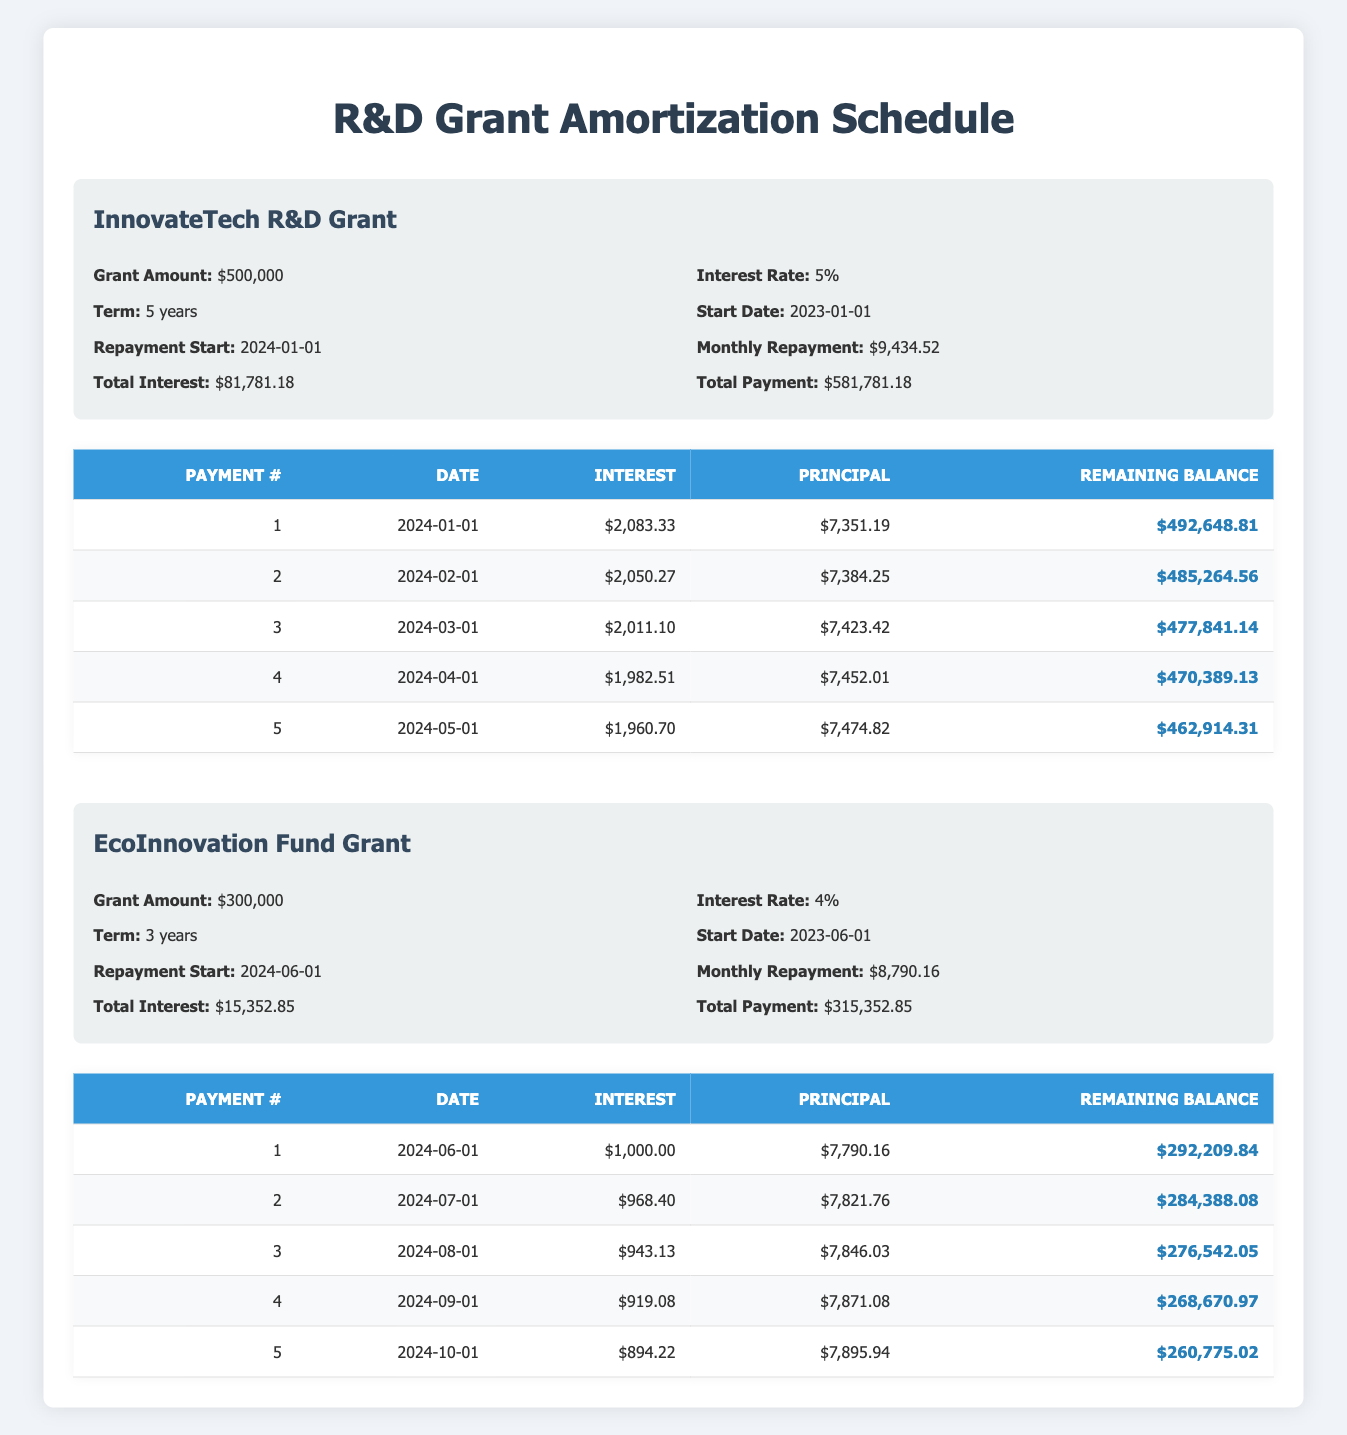What is the total payment amount for the InnovateTech R&D Grant? According to the table, the total payment for the InnovateTech R&D Grant is listed as $581,781.18.
Answer: $581,781.18 What is the remaining balance after the second payment for the EcoInnovation Fund Grant? From the payment schedule, after the second payment, the remaining balance for the EcoInnovation Fund Grant is $284,388.08.
Answer: $284,388.08 Is the monthly repayment amount for the InnovateTech R&D Grant higher than that for the EcoInnovation Fund Grant? The monthly repayment for the InnovateTech R&D Grant is $9,434.52, while for the EcoInnovation Fund Grant, it is $8,790.16. Since $9,434.52 is greater than $8,790.16, the statement is true.
Answer: Yes Calculate the average interest payment in the first five months for the InnovateTech R&D Grant. The total interest payments for the first five months are $2,083.33 + $2,050.27 + $2,011.10 + $1,982.51 + $1,960.70 = $10,087.91. Dividing this by 5 gives an average of $10,087.91 / 5 = $2,017.58.
Answer: $2,017.58 What is the difference between the total interest of the two grants? The total interest for the InnovateTech R&D Grant is $81,781.18 and for the EcoInnovation Fund Grant, it is $15,352.85. The difference is $81,781.18 - $15,352.85 = $66,428.33.
Answer: $66,428.33 How many principal payments exceed $7,400 for the InnovateTech R&D Grant? Looking at the principal payments listed for each month, the amounts are $7,351.19, $7,384.25, $7,423.42, $7,452.01, and $7,474.82. The last four payments exceed $7,400 — hence, there are four payments that exceed this amount.
Answer: 4 What is the remaining balance after the first payment of the EcoInnovation Fund Grant? The remaining balance after the first payment is shown in the payment schedule as $292,209.84 after the payment dated 2024-06-01.
Answer: $292,209.84 Does the interest payment increase with each subsequent payment for the EcoInnovation Fund Grant? Analyzing the interest payments, they are $1,000.00, $968.40, $943.13, $919.08, and $894.22, indicating that the interest payments decrease rather than increase. Thus, the statement is false.
Answer: No 